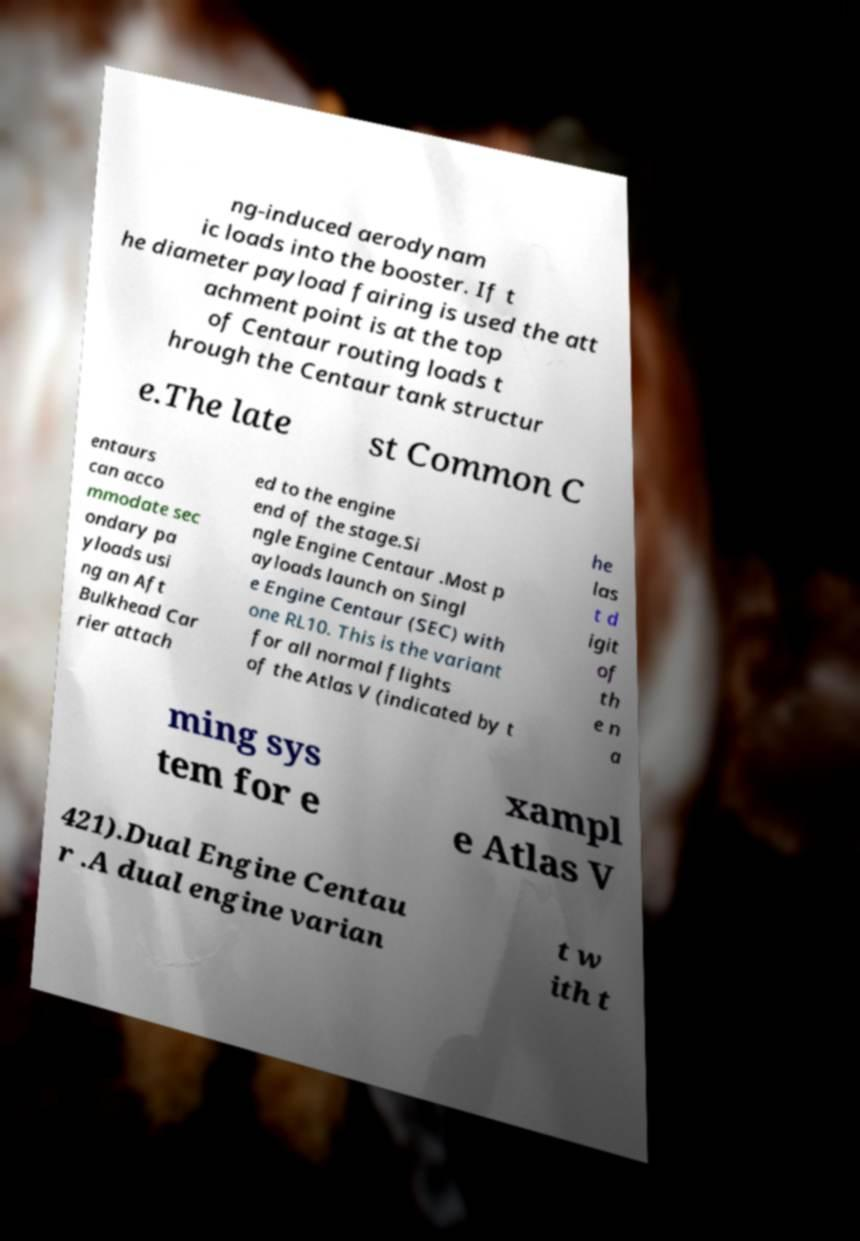Can you accurately transcribe the text from the provided image for me? ng-induced aerodynam ic loads into the booster. If t he diameter payload fairing is used the att achment point is at the top of Centaur routing loads t hrough the Centaur tank structur e.The late st Common C entaurs can acco mmodate sec ondary pa yloads usi ng an Aft Bulkhead Car rier attach ed to the engine end of the stage.Si ngle Engine Centaur .Most p ayloads launch on Singl e Engine Centaur (SEC) with one RL10. This is the variant for all normal flights of the Atlas V (indicated by t he las t d igit of th e n a ming sys tem for e xampl e Atlas V 421).Dual Engine Centau r .A dual engine varian t w ith t 